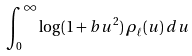<formula> <loc_0><loc_0><loc_500><loc_500>\int _ { 0 } ^ { \infty } \log ( 1 + b u ^ { 2 } ) \, \rho _ { \ell } ( u ) \, d u</formula> 